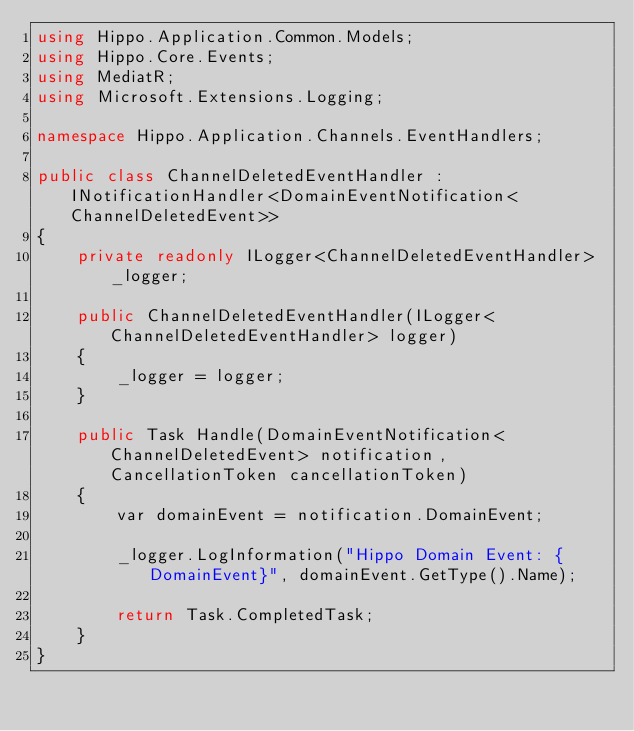<code> <loc_0><loc_0><loc_500><loc_500><_C#_>using Hippo.Application.Common.Models;
using Hippo.Core.Events;
using MediatR;
using Microsoft.Extensions.Logging;

namespace Hippo.Application.Channels.EventHandlers;

public class ChannelDeletedEventHandler : INotificationHandler<DomainEventNotification<ChannelDeletedEvent>>
{
    private readonly ILogger<ChannelDeletedEventHandler> _logger;

    public ChannelDeletedEventHandler(ILogger<ChannelDeletedEventHandler> logger)
    {
        _logger = logger;
    }

    public Task Handle(DomainEventNotification<ChannelDeletedEvent> notification, CancellationToken cancellationToken)
    {
        var domainEvent = notification.DomainEvent;

        _logger.LogInformation("Hippo Domain Event: {DomainEvent}", domainEvent.GetType().Name);

        return Task.CompletedTask;
    }
}
</code> 